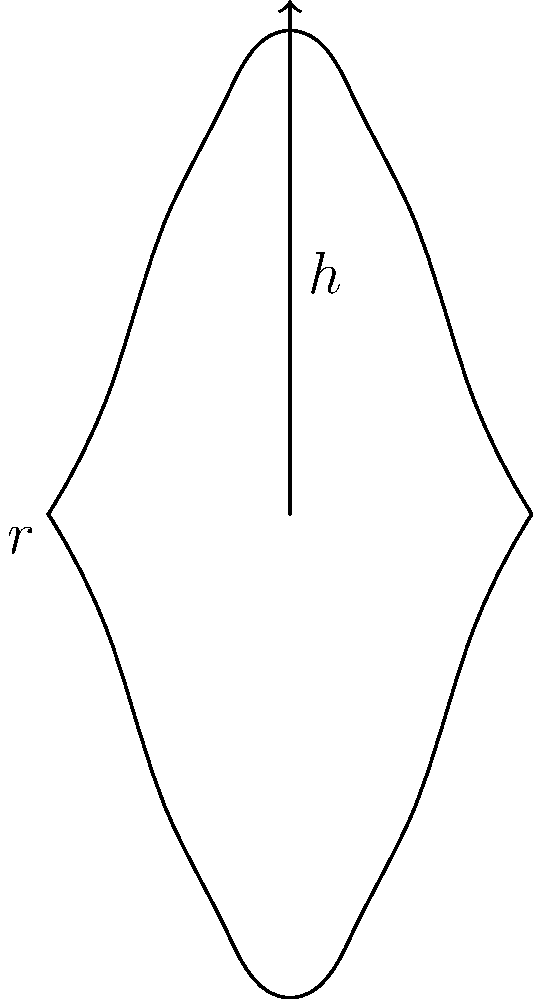An ancient Greek amphora can be modeled by rotating the curve $y = 4\sin(\frac{\pi x}{8})$ around the y-axis from $x = 0$ to $x = 8$. Using the traditional method of cylindrical shells, calculate the volume of the amphora. Round your answer to the nearest cubic unit. To solve this problem using the traditional method of cylindrical shells, we'll follow these steps:

1) The volume formula using cylindrical shells is:
   $$V = 2\pi \int_a^b xf(x)dx$$

2) In our case, $f(x) = 4\sin(\frac{\pi x}{8})$, $a = 0$, and $b = 8$

3) Substituting into the formula:
   $$V = 2\pi \int_0^8 x(4\sin(\frac{\pi x}{8}))dx$$

4) Simplify:
   $$V = 8\pi \int_0^8 x\sin(\frac{\pi x}{8})dx$$

5) This integral can be solved using integration by parts. Let $u = x$ and $dv = \sin(\frac{\pi x}{8})dx$

6) After integration by parts and simplification, we get:
   $$V = 8\pi [-\frac{64}{\pi}\cos(\frac{\pi x}{8}) + \frac{8x}{\pi}\sin(\frac{\pi x}{8})]_0^8$$

7) Evaluate at the limits:
   $$V = 8\pi [-\frac{64}{\pi}(-1) + \frac{64}{\pi}(0) - (-\frac{64}{\pi}(1) + 0)]$$

8) Simplify:
   $$V = 8\pi [\frac{128}{\pi}] = 1024$$

9) Rounding to the nearest cubic unit:
   $$V \approx 1024 \text{ cubic units}$$
Answer: 1024 cubic units 